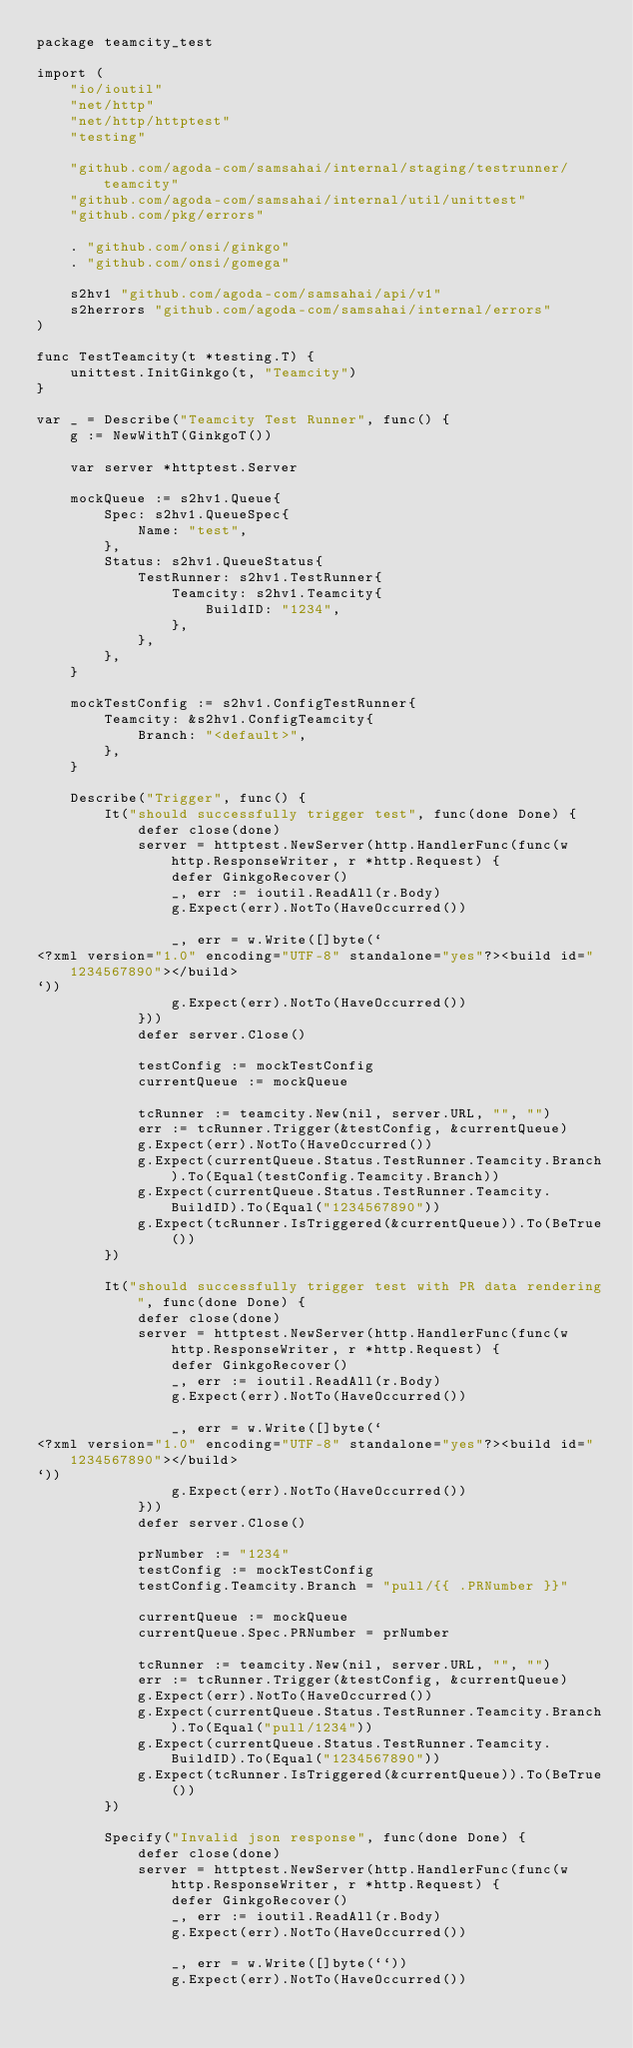Convert code to text. <code><loc_0><loc_0><loc_500><loc_500><_Go_>package teamcity_test

import (
	"io/ioutil"
	"net/http"
	"net/http/httptest"
	"testing"

	"github.com/agoda-com/samsahai/internal/staging/testrunner/teamcity"
	"github.com/agoda-com/samsahai/internal/util/unittest"
	"github.com/pkg/errors"

	. "github.com/onsi/ginkgo"
	. "github.com/onsi/gomega"

	s2hv1 "github.com/agoda-com/samsahai/api/v1"
	s2herrors "github.com/agoda-com/samsahai/internal/errors"
)

func TestTeamcity(t *testing.T) {
	unittest.InitGinkgo(t, "Teamcity")
}

var _ = Describe("Teamcity Test Runner", func() {
	g := NewWithT(GinkgoT())

	var server *httptest.Server

	mockQueue := s2hv1.Queue{
		Spec: s2hv1.QueueSpec{
			Name: "test",
		},
		Status: s2hv1.QueueStatus{
			TestRunner: s2hv1.TestRunner{
				Teamcity: s2hv1.Teamcity{
					BuildID: "1234",
				},
			},
		},
	}

	mockTestConfig := s2hv1.ConfigTestRunner{
		Teamcity: &s2hv1.ConfigTeamcity{
			Branch: "<default>",
		},
	}

	Describe("Trigger", func() {
		It("should successfully trigger test", func(done Done) {
			defer close(done)
			server = httptest.NewServer(http.HandlerFunc(func(w http.ResponseWriter, r *http.Request) {
				defer GinkgoRecover()
				_, err := ioutil.ReadAll(r.Body)
				g.Expect(err).NotTo(HaveOccurred())

				_, err = w.Write([]byte(`
<?xml version="1.0" encoding="UTF-8" standalone="yes"?><build id="1234567890"></build>
`))
				g.Expect(err).NotTo(HaveOccurred())
			}))
			defer server.Close()

			testConfig := mockTestConfig
			currentQueue := mockQueue

			tcRunner := teamcity.New(nil, server.URL, "", "")
			err := tcRunner.Trigger(&testConfig, &currentQueue)
			g.Expect(err).NotTo(HaveOccurred())
			g.Expect(currentQueue.Status.TestRunner.Teamcity.Branch).To(Equal(testConfig.Teamcity.Branch))
			g.Expect(currentQueue.Status.TestRunner.Teamcity.BuildID).To(Equal("1234567890"))
			g.Expect(tcRunner.IsTriggered(&currentQueue)).To(BeTrue())
		})

		It("should successfully trigger test with PR data rendering", func(done Done) {
			defer close(done)
			server = httptest.NewServer(http.HandlerFunc(func(w http.ResponseWriter, r *http.Request) {
				defer GinkgoRecover()
				_, err := ioutil.ReadAll(r.Body)
				g.Expect(err).NotTo(HaveOccurred())

				_, err = w.Write([]byte(`
<?xml version="1.0" encoding="UTF-8" standalone="yes"?><build id="1234567890"></build>
`))
				g.Expect(err).NotTo(HaveOccurred())
			}))
			defer server.Close()

			prNumber := "1234"
			testConfig := mockTestConfig
			testConfig.Teamcity.Branch = "pull/{{ .PRNumber }}"

			currentQueue := mockQueue
			currentQueue.Spec.PRNumber = prNumber

			tcRunner := teamcity.New(nil, server.URL, "", "")
			err := tcRunner.Trigger(&testConfig, &currentQueue)
			g.Expect(err).NotTo(HaveOccurred())
			g.Expect(currentQueue.Status.TestRunner.Teamcity.Branch).To(Equal("pull/1234"))
			g.Expect(currentQueue.Status.TestRunner.Teamcity.BuildID).To(Equal("1234567890"))
			g.Expect(tcRunner.IsTriggered(&currentQueue)).To(BeTrue())
		})

		Specify("Invalid json response", func(done Done) {
			defer close(done)
			server = httptest.NewServer(http.HandlerFunc(func(w http.ResponseWriter, r *http.Request) {
				defer GinkgoRecover()
				_, err := ioutil.ReadAll(r.Body)
				g.Expect(err).NotTo(HaveOccurred())

				_, err = w.Write([]byte(``))
				g.Expect(err).NotTo(HaveOccurred())</code> 